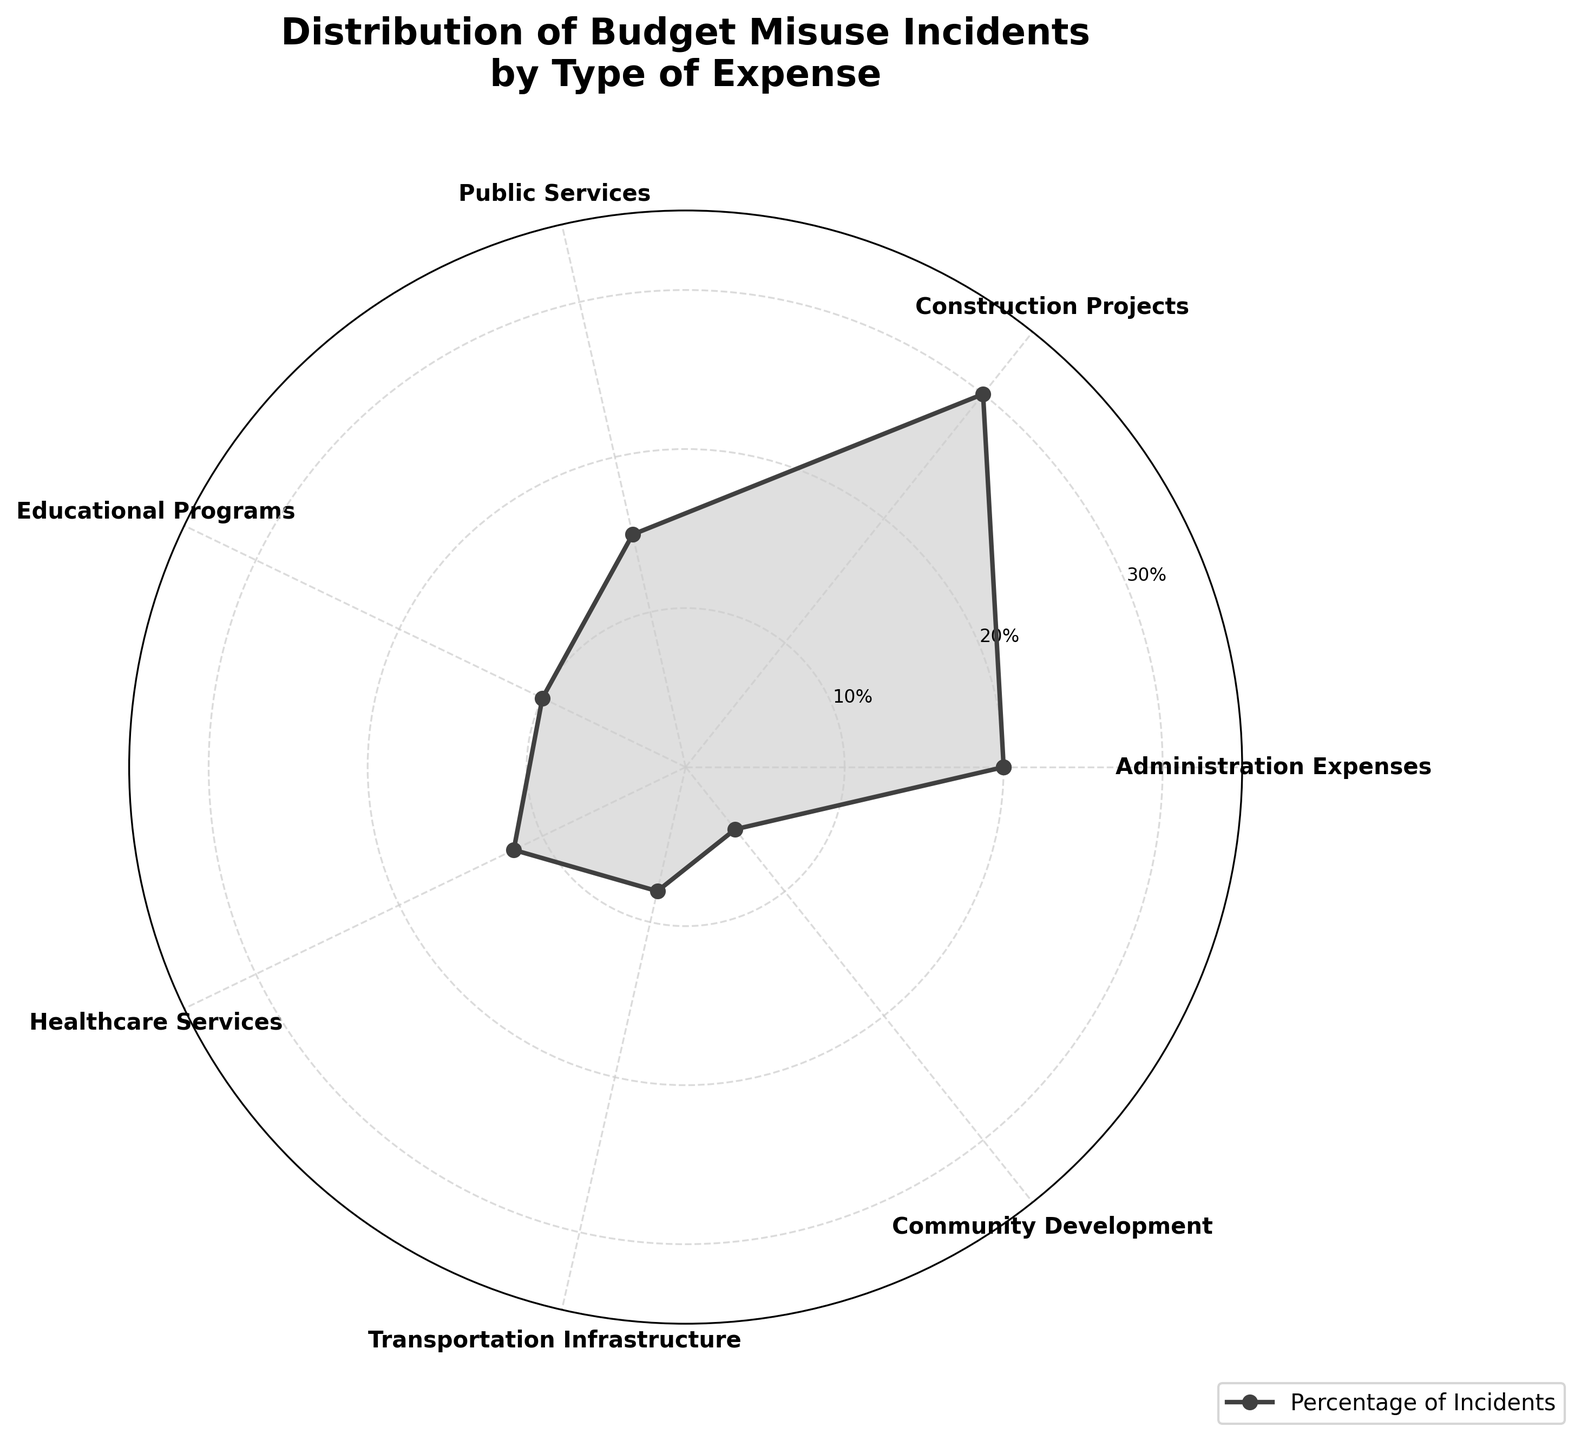What percentage of incidents are attributed to Administration Expenses? The radar chart segments budget misuse incidents by type of expense. The section labeled "Administration Expenses" shows a value of 20%.
Answer: 20% Which category has the highest percentage of budget misuse incidents? The radar chart shows a series of categories with their respective percentages. The highest value corresponds to "Construction Projects" with 30%.
Answer: Construction Projects What is the combined percentage of incidents for Public Services and Educational Programs? Public Services have 15%, and Educational Programs have 10%. Adding these together gives 15% + 10% = 25%.
Answer: 25% Which types of expense have less than 10% of the incidents? On the radar chart, the segments for "Transportation Infrastructure" and "Community Development" fall short of the 10% mark, with 8% and 5% respectively.
Answer: Transportation Infrastructure, Community Development How many types of expenses are charted in the radar chart? By counting the labeled sections on the radar chart, we see seven different types of expenses.
Answer: 7 What is the difference in the percentage of incidents between Healthcare Services and Administration Expenses? Healthcare Services are at 12%, and Administration Expenses are at 20%. The difference is 20% - 12% = 8%.
Answer: 8% What percentage of incidents fall under Community Development, and how does this compare to the highest category? Community Development accounts for 5% of incidents, whereas the highest category, Construction Projects, accounts for 30%. The difference is 30% - 5% = 25%.
Answer: 5%, 25% Which types of expenses have their values above the 10% radial tick? The 10% radial tick line is exceeded by Administration Expenses (20%), Construction Projects (30%), Public Services (15%), and Healthcare Services (12%).
Answer: Administration Expenses, Construction Projects, Public Services, Healthcare Services 